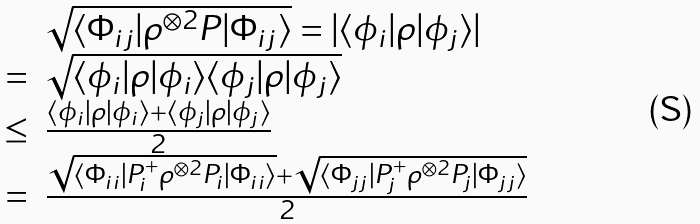Convert formula to latex. <formula><loc_0><loc_0><loc_500><loc_500>\begin{array} { r l } & \sqrt { \langle \Phi _ { i j } | \rho ^ { \otimes 2 } P | \Phi _ { i j } \rangle } = | \langle \phi _ { i } | \rho | \phi _ { j } \rangle | \\ = & \sqrt { \langle \phi _ { i } | \rho | \phi _ { i } \rangle \langle \phi _ { j } | \rho | \phi _ { j } \rangle } \\ \leq & \frac { \langle \phi _ { i } | \rho | \phi _ { i } \rangle + \langle \phi _ { j } | \rho | \phi _ { j } \rangle } { 2 } \\ = & \frac { \sqrt { \langle \Phi _ { i i } | P _ { i } ^ { + } \rho ^ { \otimes 2 } P _ { i } | \Phi _ { i i } \rangle } + \sqrt { \langle \Phi _ { j j } | P _ { j } ^ { + } \rho ^ { \otimes 2 } P _ { j } | \Phi _ { j j } \rangle } } { 2 } \end{array}</formula> 